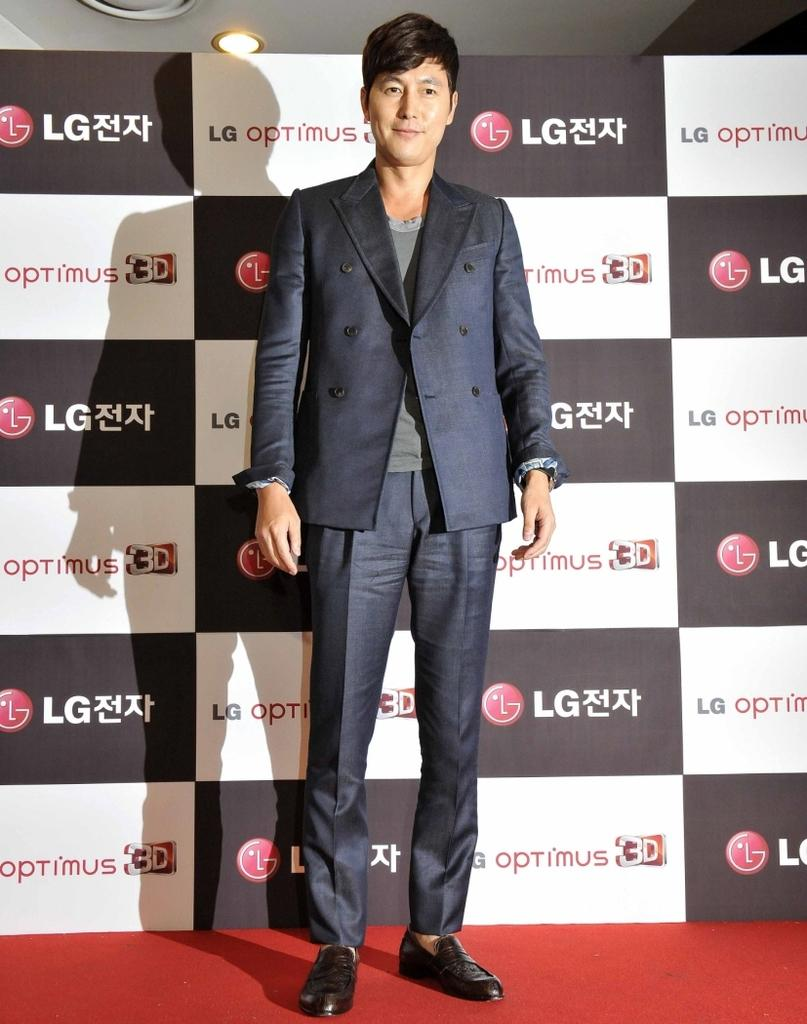What is the person in the image wearing? The person is wearing a suit in the image. Where is the person located in the image? The person is in the center of the image. What can be seen in the background of the image? There is an advertisement board in the background of the image. What color is the carpet at the bottom of the image? The carpet at the bottom of the image is red. What type of smell is associated with the cows in the image? There are no cows present in the image, so there is no smell associated with them. 